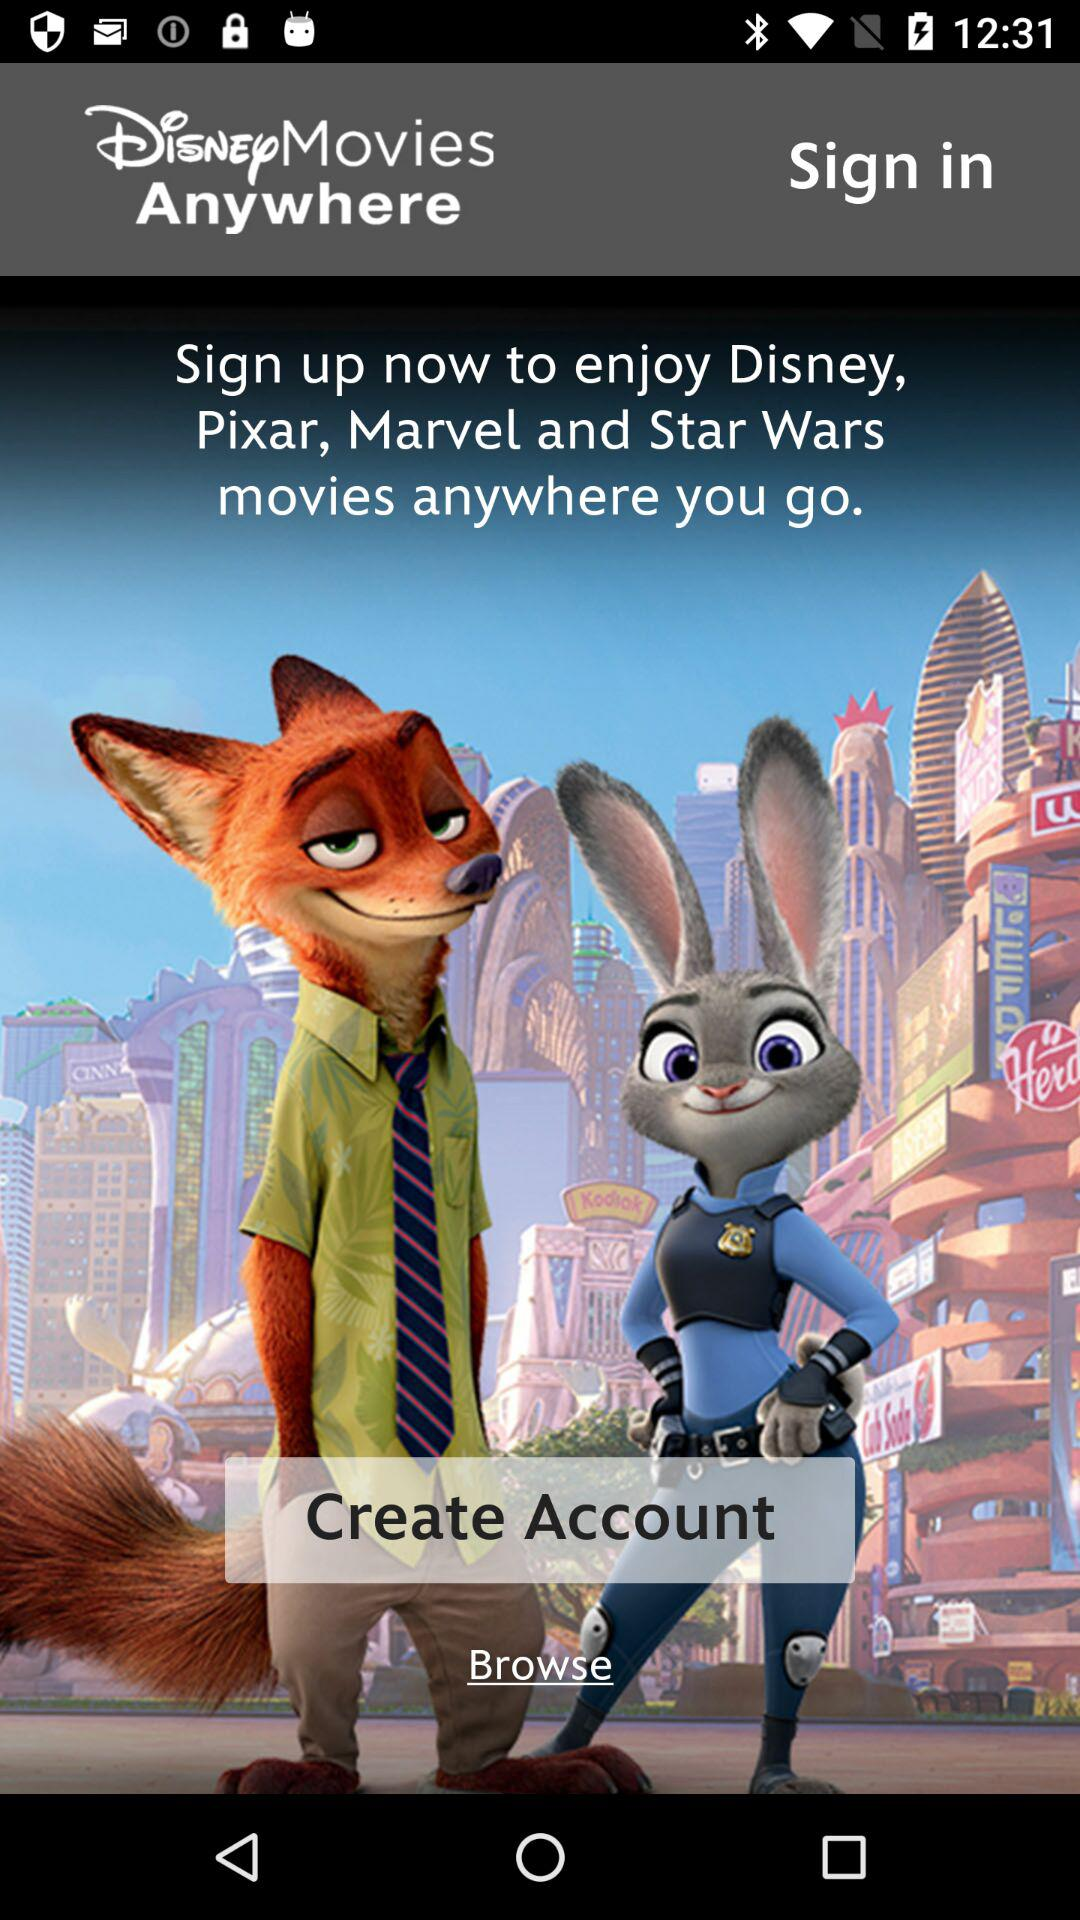What is the application name? The application name is "Disney Movies Anywhere". 